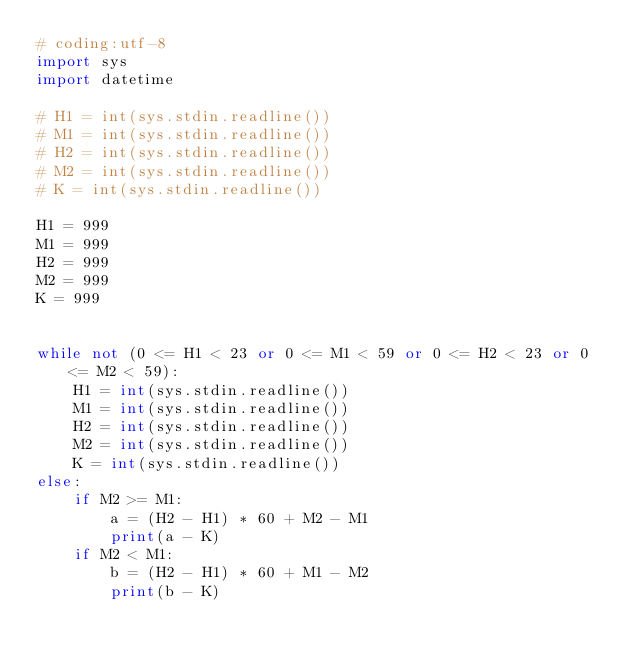Convert code to text. <code><loc_0><loc_0><loc_500><loc_500><_Python_># coding:utf-8
import sys
import datetime

# H1 = int(sys.stdin.readline())
# M1 = int(sys.stdin.readline())
# H2 = int(sys.stdin.readline())
# M2 = int(sys.stdin.readline())
# K = int(sys.stdin.readline())

H1 = 999
M1 = 999
H2 = 999
M2 = 999
K = 999


while not (0 <= H1 < 23 or 0 <= M1 < 59 or 0 <= H2 < 23 or 0 <= M2 < 59):
    H1 = int(sys.stdin.readline())
    M1 = int(sys.stdin.readline())
    H2 = int(sys.stdin.readline())
    M2 = int(sys.stdin.readline())
    K = int(sys.stdin.readline())
else:
    if M2 >= M1:
        a = (H2 - H1) * 60 + M2 - M1
        print(a - K)
    if M2 < M1:
        b = (H2 - H1) * 60 + M1 - M2
        print(b - K)</code> 